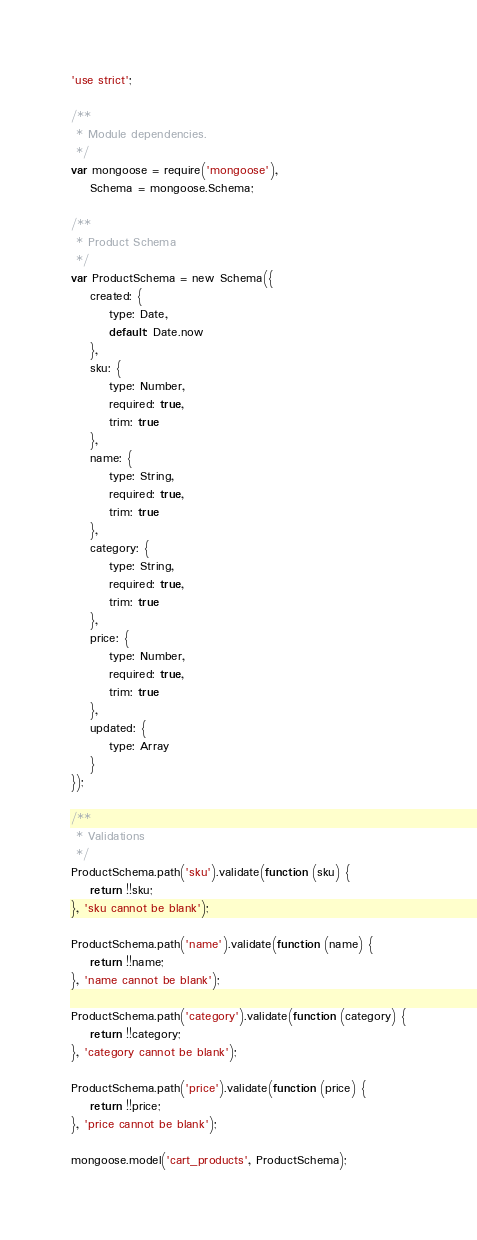Convert code to text. <code><loc_0><loc_0><loc_500><loc_500><_JavaScript_>'use strict';

/**
 * Module dependencies.
 */
var mongoose = require('mongoose'),
    Schema = mongoose.Schema;

/**
 * Product Schema
 */
var ProductSchema = new Schema({
    created: {
        type: Date,
        default: Date.now
    },
    sku: {
        type: Number,
        required: true,
        trim: true
    },
    name: {
        type: String,
        required: true,
        trim: true
    },
    category: {
        type: String,
        required: true,
        trim: true
    },
    price: {
        type: Number,
        required: true,
        trim: true
    },
    updated: {
        type: Array
    }
});

/**
 * Validations
 */
ProductSchema.path('sku').validate(function (sku) {
    return !!sku;
}, 'sku cannot be blank');

ProductSchema.path('name').validate(function (name) {
    return !!name;
}, 'name cannot be blank');

ProductSchema.path('category').validate(function (category) {
    return !!category;
}, 'category cannot be blank');

ProductSchema.path('price').validate(function (price) {
    return !!price;
}, 'price cannot be blank');

mongoose.model('cart_products', ProductSchema);</code> 